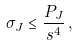<formula> <loc_0><loc_0><loc_500><loc_500>\sigma _ { J } \leq \frac { P _ { J } } { s ^ { 4 } } \, ,</formula> 